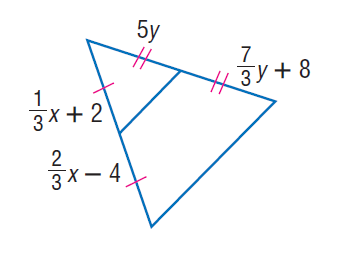Question: Find x.
Choices:
A. 16
B. 18
C. 24
D. 27
Answer with the letter. Answer: B Question: Find y.
Choices:
A. 2.2
B. 3
C. 5
D. 6
Answer with the letter. Answer: B 